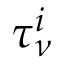<formula> <loc_0><loc_0><loc_500><loc_500>\tau _ { \nu } ^ { i }</formula> 